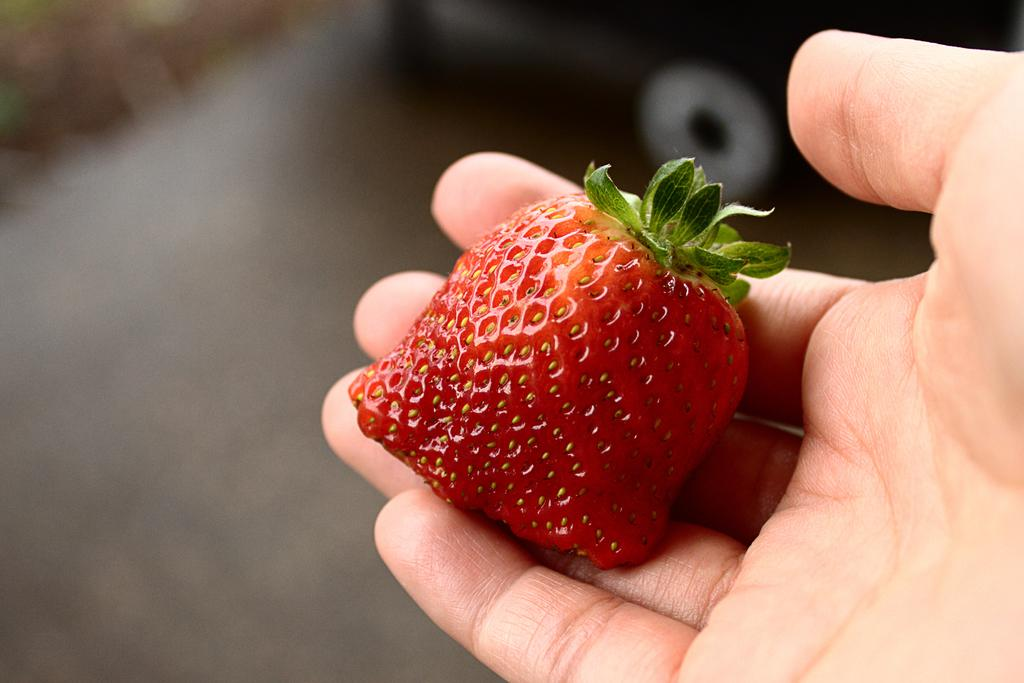What is the person in the image holding? The person is holding fruit in the image. Can you describe the background of the image? The background of the image is blurry. How far away is the fish from the person in the image? There is no fish present in the image, so it is not possible to determine the distance between the person and a fish. 